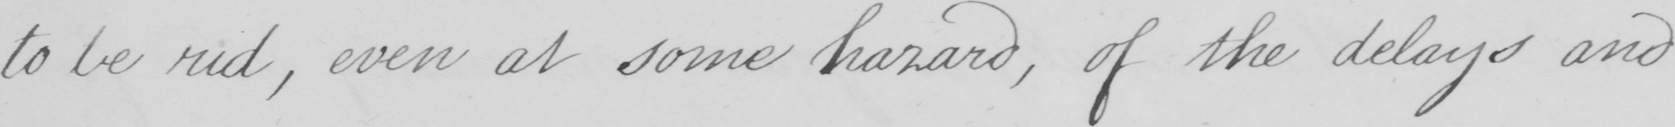Transcribe the text shown in this historical manuscript line. to be rid , even at some hazard , of the delays and 